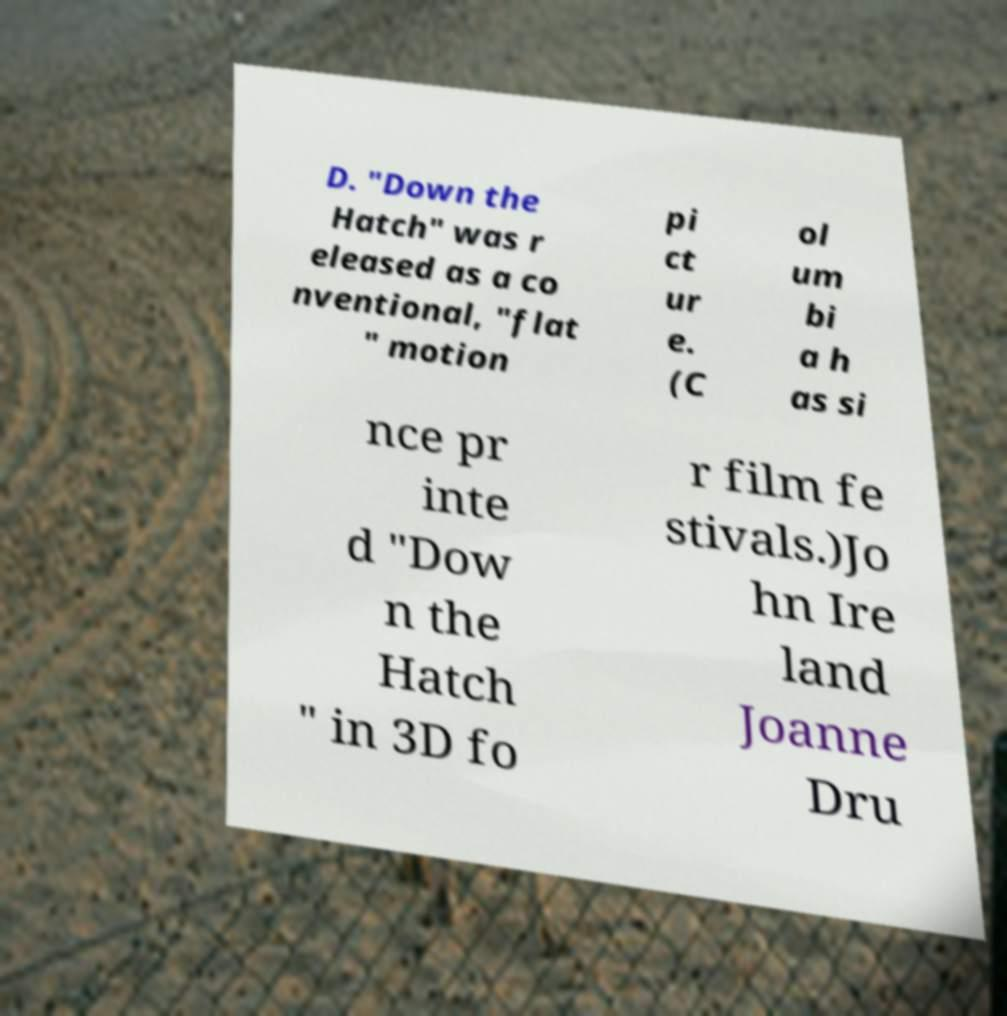Can you read and provide the text displayed in the image?This photo seems to have some interesting text. Can you extract and type it out for me? D. "Down the Hatch" was r eleased as a co nventional, "flat " motion pi ct ur e. (C ol um bi a h as si nce pr inte d "Dow n the Hatch " in 3D fo r film fe stivals.)Jo hn Ire land Joanne Dru 